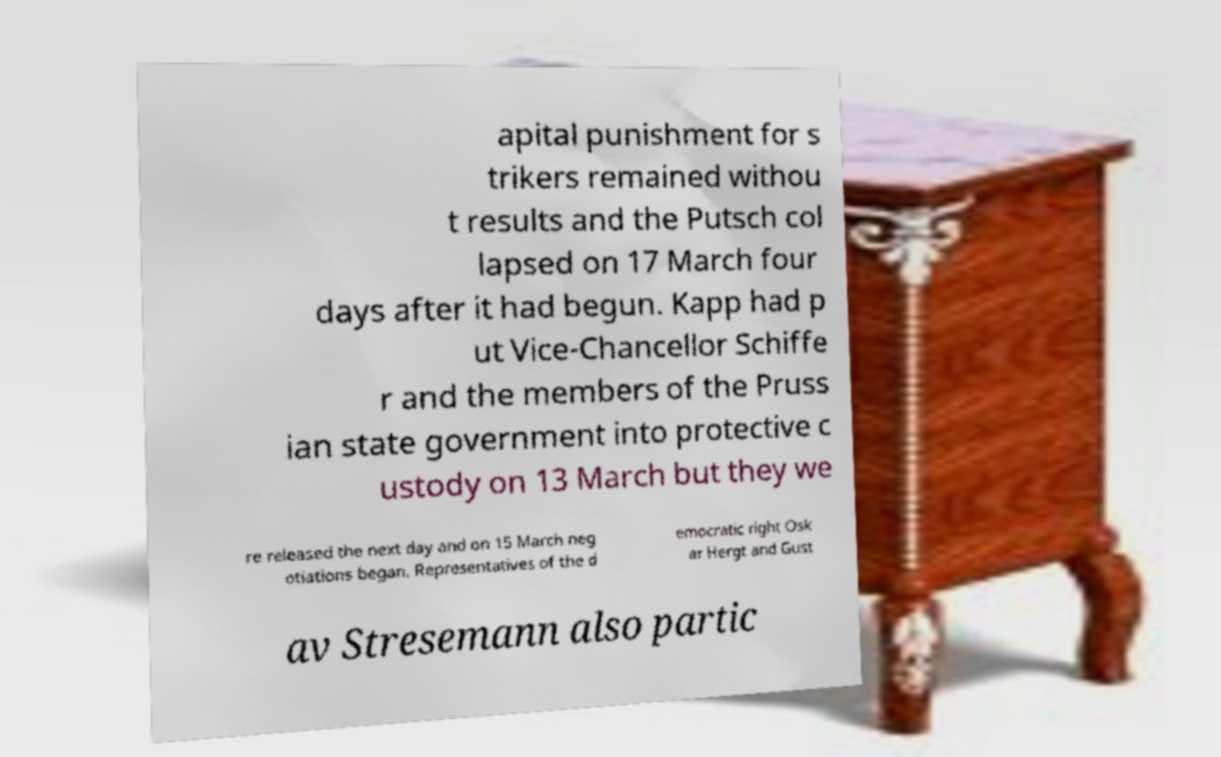Could you assist in decoding the text presented in this image and type it out clearly? apital punishment for s trikers remained withou t results and the Putsch col lapsed on 17 March four days after it had begun. Kapp had p ut Vice-Chancellor Schiffe r and the members of the Pruss ian state government into protective c ustody on 13 March but they we re released the next day and on 15 March neg otiations began. Representatives of the d emocratic right Osk ar Hergt and Gust av Stresemann also partic 